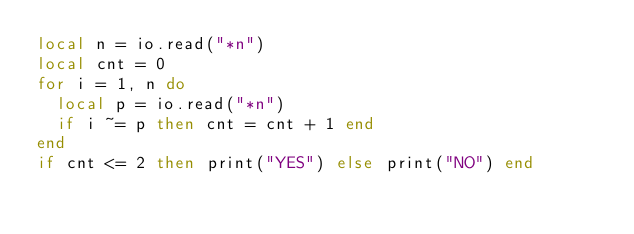<code> <loc_0><loc_0><loc_500><loc_500><_Lua_>local n = io.read("*n")
local cnt = 0
for i = 1, n do
  local p = io.read("*n")
  if i ~= p then cnt = cnt + 1 end
end
if cnt <= 2 then print("YES") else print("NO") end
</code> 